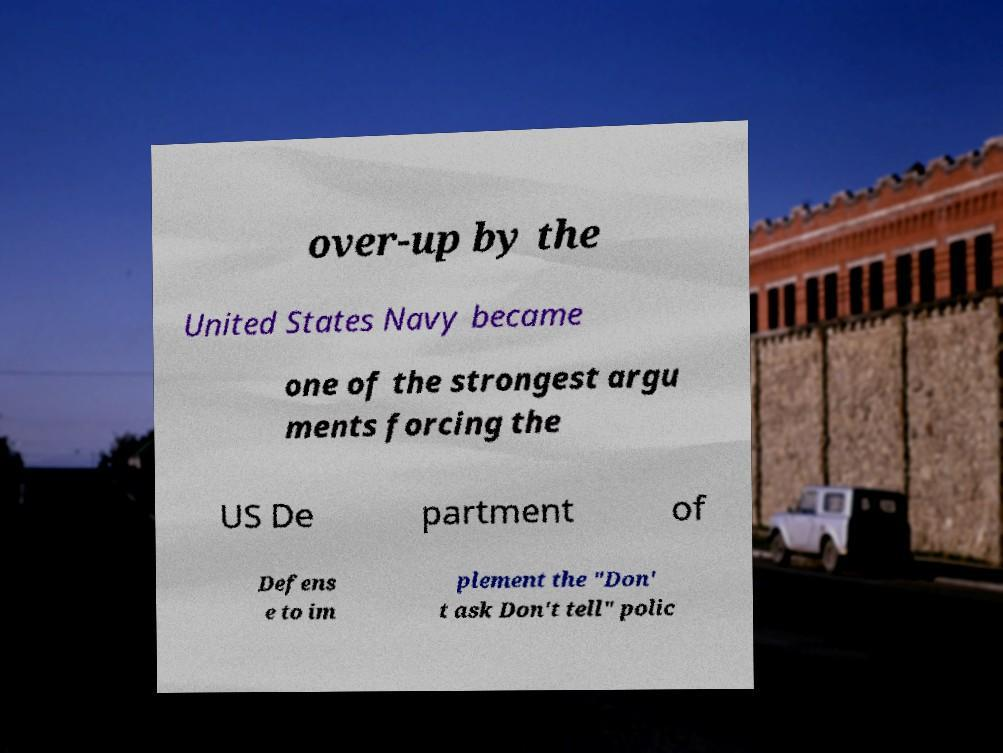Could you extract and type out the text from this image? over-up by the United States Navy became one of the strongest argu ments forcing the US De partment of Defens e to im plement the "Don' t ask Don't tell" polic 